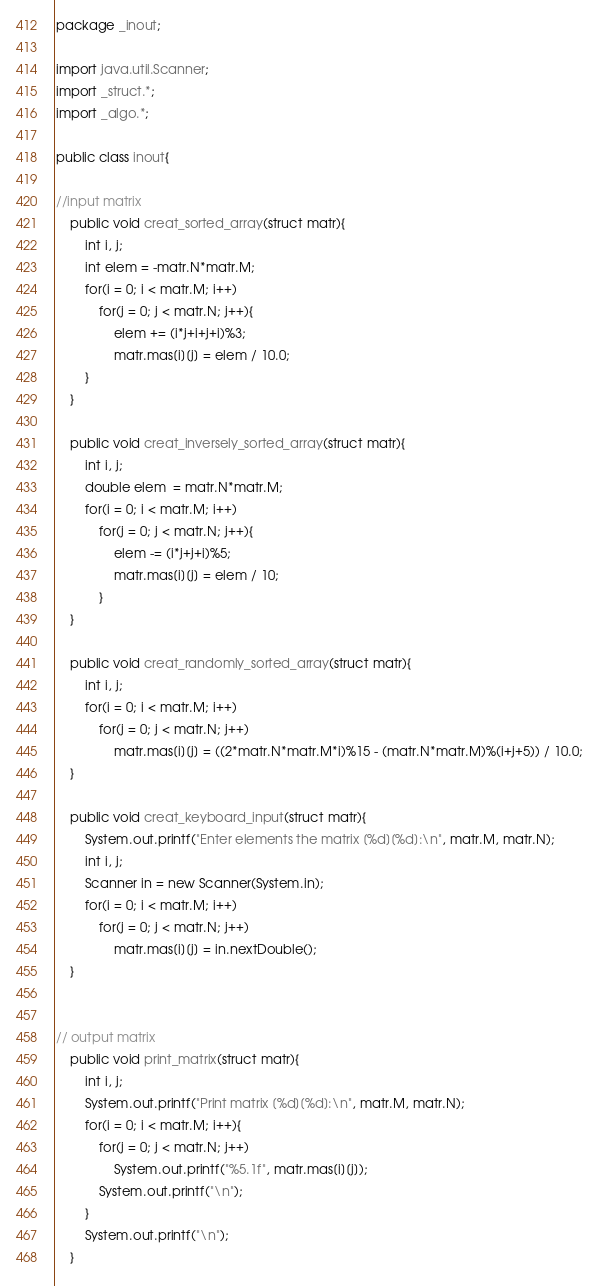Convert code to text. <code><loc_0><loc_0><loc_500><loc_500><_Java_>package _inout;

import java.util.Scanner;
import _struct.*;
import _algo.*;

public class inout{

//input matrix
	public void creat_sorted_array(struct matr){
		int i, j;
		int elem = -matr.N*matr.M;
		for(i = 0; i < matr.M; i++)
			for(j = 0; j < matr.N; j++){
				elem += (i*j+i+j+i)%3;
				matr.mas[i][j] = elem / 10.0;
		}
	}

	public void creat_inversely_sorted_array(struct matr){
		int i, j;
		double elem  = matr.N*matr.M;
		for(i = 0; i < matr.M; i++)
			for(j = 0; j < matr.N; j++){
				elem -= (i*j+j+i)%5;
				matr.mas[i][j] = elem / 10;
			}
	}

	public void creat_randomly_sorted_array(struct matr){
		int i, j;
		for(i = 0; i < matr.M; i++)
			for(j = 0; j < matr.N; j++)
				matr.mas[i][j] = ((2*matr.N*matr.M*i)%15 - (matr.N*matr.M)%(i+j+5)) / 10.0;
	}
  
	public void creat_keyboard_input(struct matr){
		System.out.printf("Enter elements the matrix [%d][%d]:\n", matr.M, matr.N);
		int i, j;
		Scanner in = new Scanner(System.in);
		for(i = 0; i < matr.M; i++)
			for(j = 0; j < matr.N; j++)
				matr.mas[i][j] = in.nextDouble();
	}


// output matrix
	public void print_matrix(struct matr){
		int i, j;
		System.out.printf("Print matrix [%d][%d]:\n", matr.M, matr.N);
		for(i = 0; i < matr.M; i++){
			for(j = 0; j < matr.N; j++)
				System.out.printf("%5.1f", matr.mas[i][j]);
			System.out.printf("\n");
		}
		System.out.printf("\n");
	}
</code> 